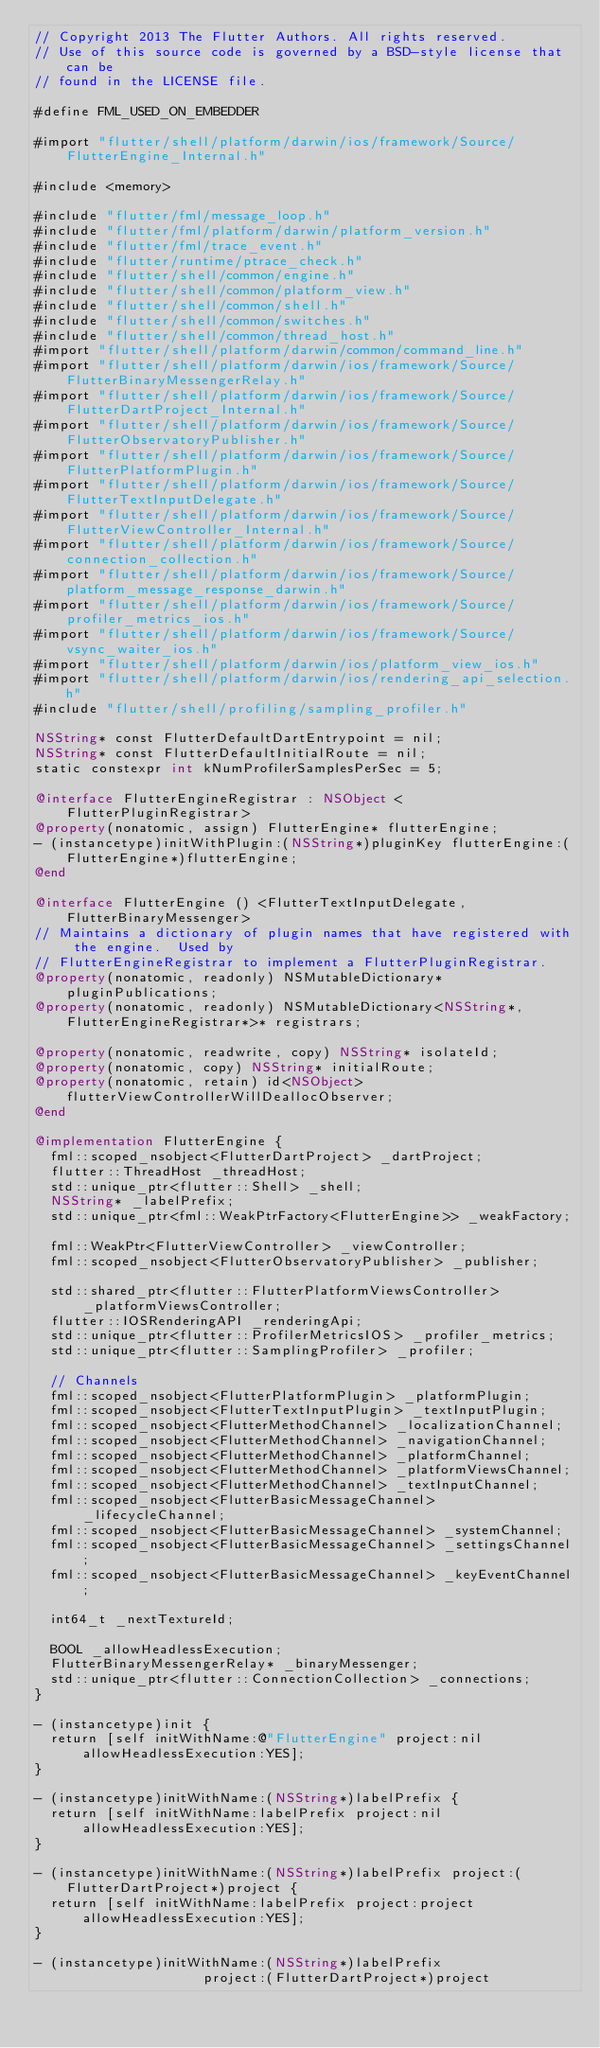Convert code to text. <code><loc_0><loc_0><loc_500><loc_500><_ObjectiveC_>// Copyright 2013 The Flutter Authors. All rights reserved.
// Use of this source code is governed by a BSD-style license that can be
// found in the LICENSE file.

#define FML_USED_ON_EMBEDDER

#import "flutter/shell/platform/darwin/ios/framework/Source/FlutterEngine_Internal.h"

#include <memory>

#include "flutter/fml/message_loop.h"
#include "flutter/fml/platform/darwin/platform_version.h"
#include "flutter/fml/trace_event.h"
#include "flutter/runtime/ptrace_check.h"
#include "flutter/shell/common/engine.h"
#include "flutter/shell/common/platform_view.h"
#include "flutter/shell/common/shell.h"
#include "flutter/shell/common/switches.h"
#include "flutter/shell/common/thread_host.h"
#import "flutter/shell/platform/darwin/common/command_line.h"
#import "flutter/shell/platform/darwin/ios/framework/Source/FlutterBinaryMessengerRelay.h"
#import "flutter/shell/platform/darwin/ios/framework/Source/FlutterDartProject_Internal.h"
#import "flutter/shell/platform/darwin/ios/framework/Source/FlutterObservatoryPublisher.h"
#import "flutter/shell/platform/darwin/ios/framework/Source/FlutterPlatformPlugin.h"
#import "flutter/shell/platform/darwin/ios/framework/Source/FlutterTextInputDelegate.h"
#import "flutter/shell/platform/darwin/ios/framework/Source/FlutterViewController_Internal.h"
#import "flutter/shell/platform/darwin/ios/framework/Source/connection_collection.h"
#import "flutter/shell/platform/darwin/ios/framework/Source/platform_message_response_darwin.h"
#import "flutter/shell/platform/darwin/ios/framework/Source/profiler_metrics_ios.h"
#import "flutter/shell/platform/darwin/ios/framework/Source/vsync_waiter_ios.h"
#import "flutter/shell/platform/darwin/ios/platform_view_ios.h"
#import "flutter/shell/platform/darwin/ios/rendering_api_selection.h"
#include "flutter/shell/profiling/sampling_profiler.h"

NSString* const FlutterDefaultDartEntrypoint = nil;
NSString* const FlutterDefaultInitialRoute = nil;
static constexpr int kNumProfilerSamplesPerSec = 5;

@interface FlutterEngineRegistrar : NSObject <FlutterPluginRegistrar>
@property(nonatomic, assign) FlutterEngine* flutterEngine;
- (instancetype)initWithPlugin:(NSString*)pluginKey flutterEngine:(FlutterEngine*)flutterEngine;
@end

@interface FlutterEngine () <FlutterTextInputDelegate, FlutterBinaryMessenger>
// Maintains a dictionary of plugin names that have registered with the engine.  Used by
// FlutterEngineRegistrar to implement a FlutterPluginRegistrar.
@property(nonatomic, readonly) NSMutableDictionary* pluginPublications;
@property(nonatomic, readonly) NSMutableDictionary<NSString*, FlutterEngineRegistrar*>* registrars;

@property(nonatomic, readwrite, copy) NSString* isolateId;
@property(nonatomic, copy) NSString* initialRoute;
@property(nonatomic, retain) id<NSObject> flutterViewControllerWillDeallocObserver;
@end

@implementation FlutterEngine {
  fml::scoped_nsobject<FlutterDartProject> _dartProject;
  flutter::ThreadHost _threadHost;
  std::unique_ptr<flutter::Shell> _shell;
  NSString* _labelPrefix;
  std::unique_ptr<fml::WeakPtrFactory<FlutterEngine>> _weakFactory;

  fml::WeakPtr<FlutterViewController> _viewController;
  fml::scoped_nsobject<FlutterObservatoryPublisher> _publisher;

  std::shared_ptr<flutter::FlutterPlatformViewsController> _platformViewsController;
  flutter::IOSRenderingAPI _renderingApi;
  std::unique_ptr<flutter::ProfilerMetricsIOS> _profiler_metrics;
  std::unique_ptr<flutter::SamplingProfiler> _profiler;

  // Channels
  fml::scoped_nsobject<FlutterPlatformPlugin> _platformPlugin;
  fml::scoped_nsobject<FlutterTextInputPlugin> _textInputPlugin;
  fml::scoped_nsobject<FlutterMethodChannel> _localizationChannel;
  fml::scoped_nsobject<FlutterMethodChannel> _navigationChannel;
  fml::scoped_nsobject<FlutterMethodChannel> _platformChannel;
  fml::scoped_nsobject<FlutterMethodChannel> _platformViewsChannel;
  fml::scoped_nsobject<FlutterMethodChannel> _textInputChannel;
  fml::scoped_nsobject<FlutterBasicMessageChannel> _lifecycleChannel;
  fml::scoped_nsobject<FlutterBasicMessageChannel> _systemChannel;
  fml::scoped_nsobject<FlutterBasicMessageChannel> _settingsChannel;
  fml::scoped_nsobject<FlutterBasicMessageChannel> _keyEventChannel;

  int64_t _nextTextureId;

  BOOL _allowHeadlessExecution;
  FlutterBinaryMessengerRelay* _binaryMessenger;
  std::unique_ptr<flutter::ConnectionCollection> _connections;
}

- (instancetype)init {
  return [self initWithName:@"FlutterEngine" project:nil allowHeadlessExecution:YES];
}

- (instancetype)initWithName:(NSString*)labelPrefix {
  return [self initWithName:labelPrefix project:nil allowHeadlessExecution:YES];
}

- (instancetype)initWithName:(NSString*)labelPrefix project:(FlutterDartProject*)project {
  return [self initWithName:labelPrefix project:project allowHeadlessExecution:YES];
}

- (instancetype)initWithName:(NSString*)labelPrefix
                     project:(FlutterDartProject*)project</code> 